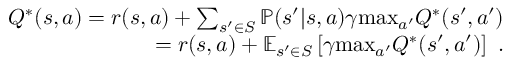<formula> <loc_0><loc_0><loc_500><loc_500>\begin{array} { r } { Q ^ { * } ( s , a ) = r ( s , a ) + \sum _ { { s ^ { \prime } \in S } } \mathbb { P } ( s ^ { \prime } | s , a ) \gamma \max _ { a ^ { \prime } } Q ^ { * } ( s ^ { \prime } , a ^ { \prime } ) } \\ { = r ( s , a ) + \mathbb { E } _ { s ^ { \prime } \in S } \left [ \gamma \max _ { a ^ { \prime } } Q ^ { * } ( s ^ { \prime } , a ^ { \prime } ) \right ] . } \end{array}</formula> 